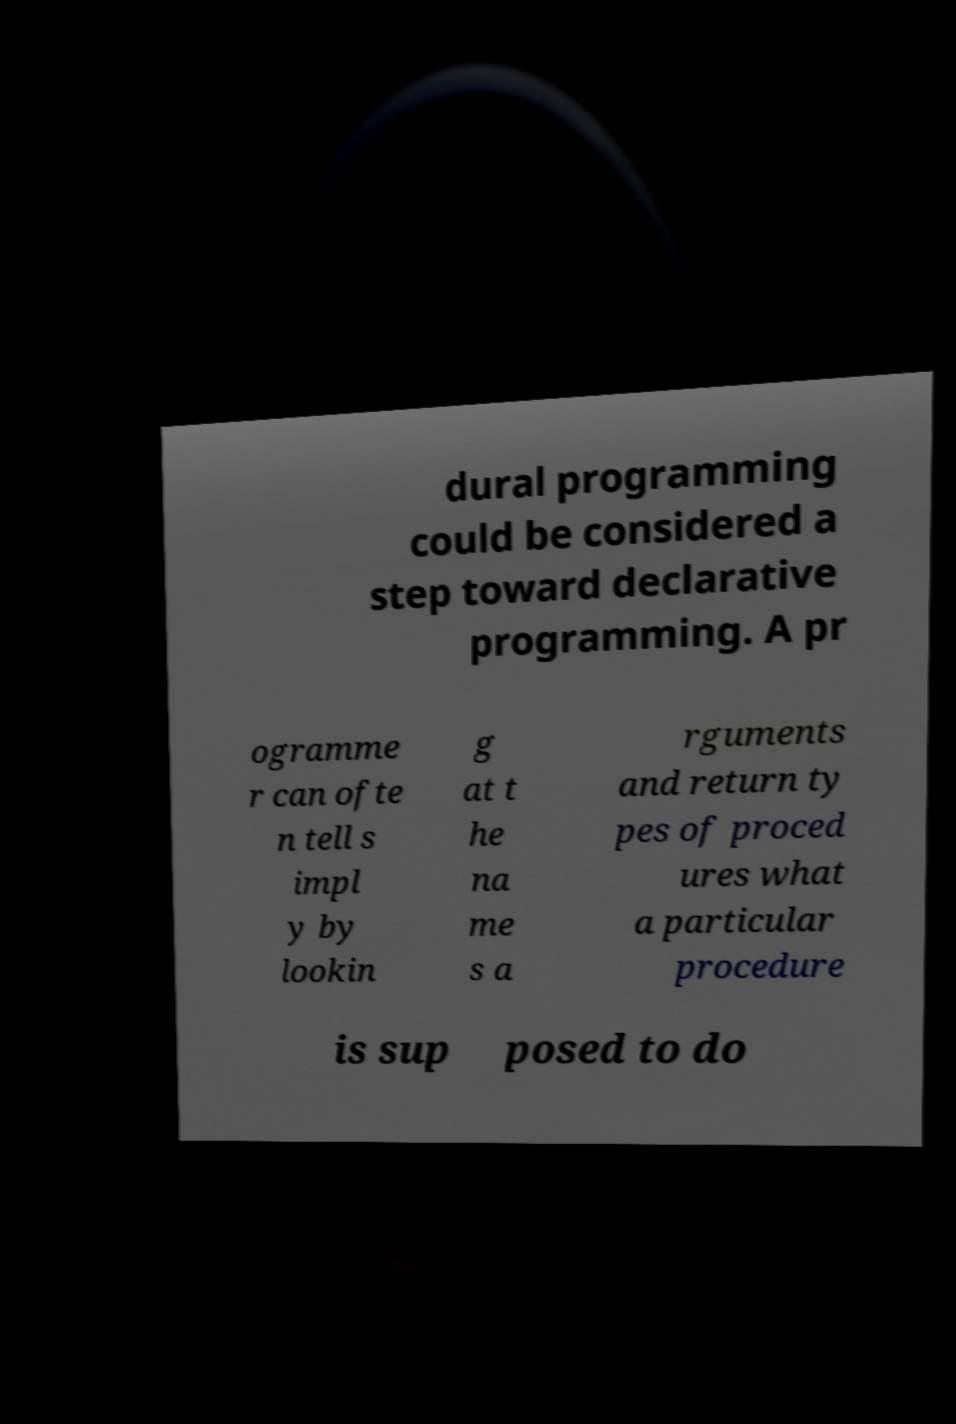Could you extract and type out the text from this image? dural programming could be considered a step toward declarative programming. A pr ogramme r can ofte n tell s impl y by lookin g at t he na me s a rguments and return ty pes of proced ures what a particular procedure is sup posed to do 